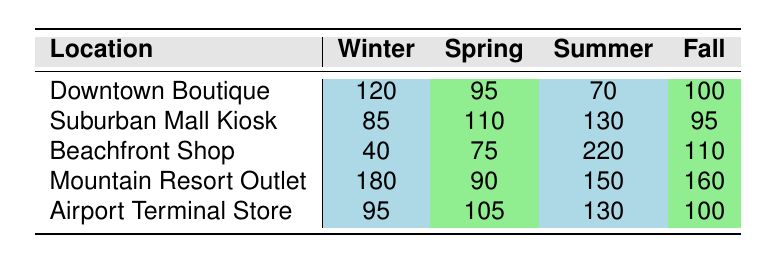What is the foot traffic for the Downtown Boutique in Winter? The table lists 120 as the foot traffic for the Downtown Boutique during the Winter season.
Answer: 120 Which location has the highest foot traffic in Summer? According to the table, the Beachfront Shop has the highest foot traffic in Summer, which is 220.
Answer: Beachfront Shop What is the total foot traffic for the Airport Terminal Store across all seasons? Summing the values for the Airport Terminal Store, we have: 95 (Winter) + 105 (Spring) + 130 (Summer) + 100 (Fall) = 430.
Answer: 430 Is the foot traffic for the Suburban Mall Kiosk higher in Spring than in Winter? Yes, the Suburban Mall Kiosk has a foot traffic of 110 in Spring, which is higher than 85 in Winter.
Answer: Yes What is the difference in foot traffic between the Beachfront Shop in Summer and the Mountain Resort Outlet in Fall? The Beachfront Shop has 220 in Summer and the Mountain Resort Outlet has 160 in Fall. The difference is 220 - 160 = 60.
Answer: 60 Which season does the Mountain Resort Outlet have the lowest foot traffic? Looking at the values, Winter has the lowest foot traffic of 180 for the Mountain Resort Outlet compared to other seasons.
Answer: Winter What is the average foot traffic for the Downtown Boutique across all seasons? The Downtown Boutique values are: 120 (Winter), 95 (Spring), 70 (Summer), 100 (Fall). Their sum is 120 + 95 + 70 + 100 = 385, and dividing by 4 seasons gives 385 / 4 = 96.25.
Answer: 96.25 Which location has consistently lower foot traffic compared to others during Winter? The Beachfront Shop has the lowest foot traffic in Winter with 40, significantly lower compared to other locations listed in that season.
Answer: Beachfront Shop What is the median foot traffic for the Spring season across all locations? The foot traffic values for Spring are: 95, 110, 75, 90, and 105. When sorted (75, 90, 95, 105, 110), the median is the middle value, which is 95.
Answer: 95 How does the foot traffic of the Suburban Mall Kiosk in Spring compare to that of the Downtown Boutique in Fall? The Suburban Mall Kiosk has 110 in Spring while the Downtown Boutique has 100 in Fall. Comparing the two, 110 is greater than 100.
Answer: Greater than 